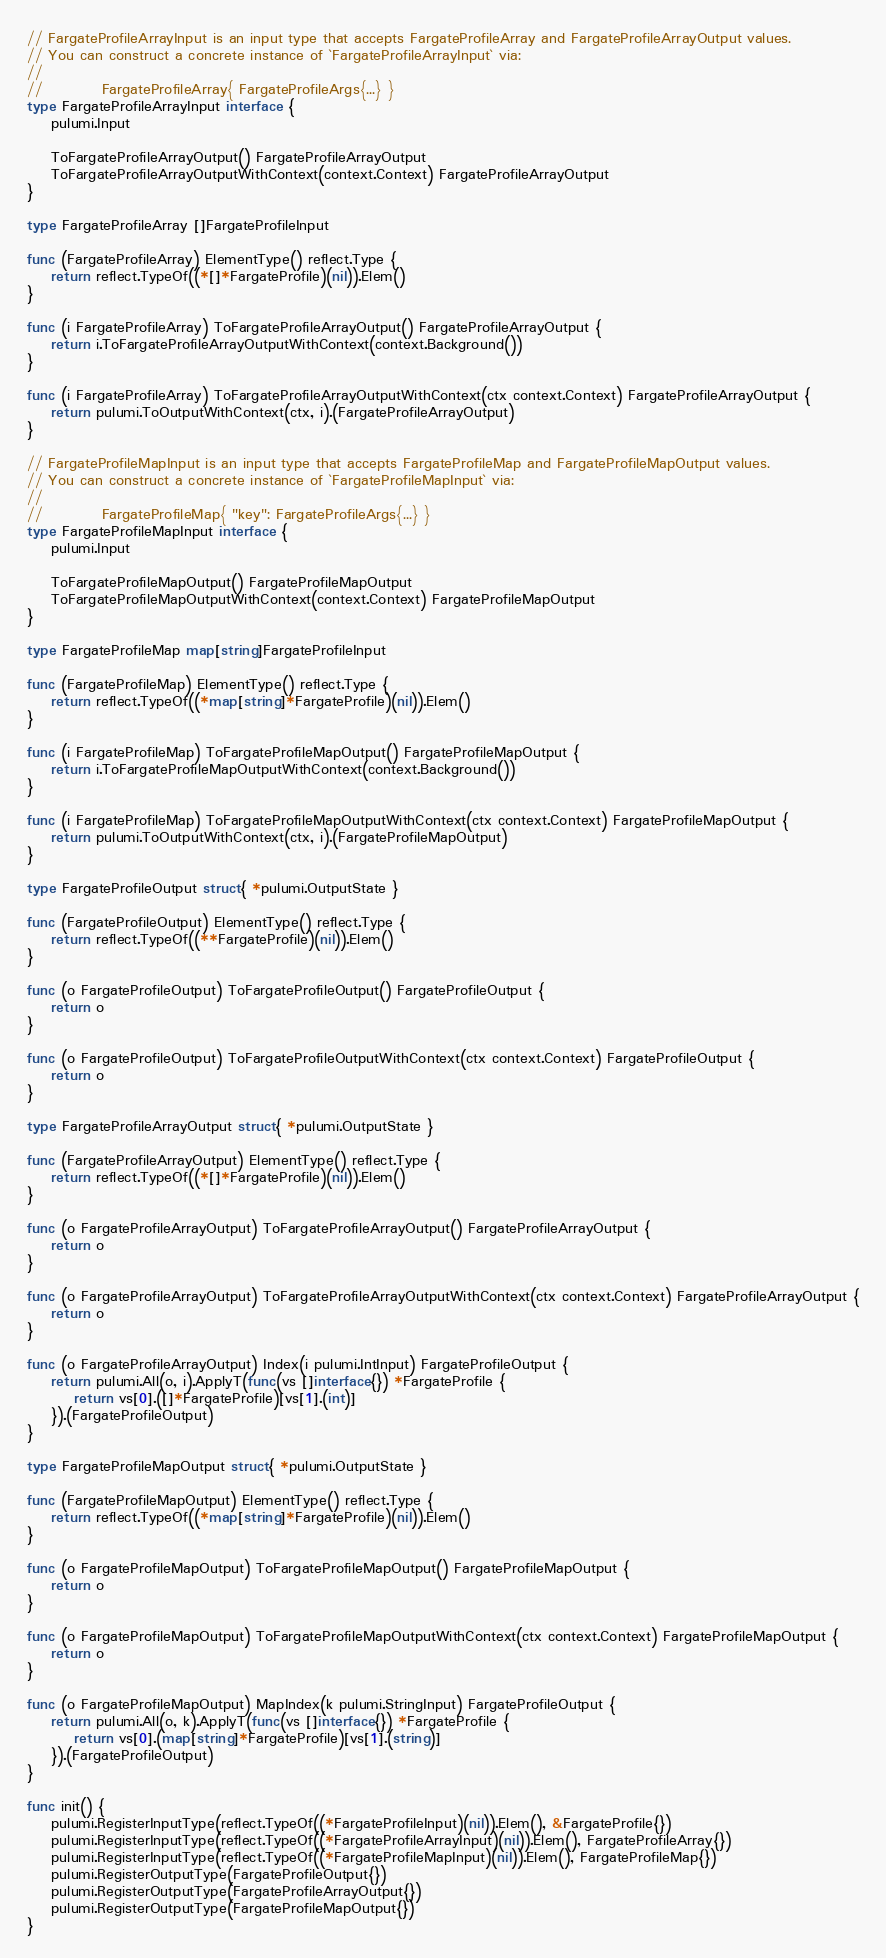<code> <loc_0><loc_0><loc_500><loc_500><_Go_>
// FargateProfileArrayInput is an input type that accepts FargateProfileArray and FargateProfileArrayOutput values.
// You can construct a concrete instance of `FargateProfileArrayInput` via:
//
//          FargateProfileArray{ FargateProfileArgs{...} }
type FargateProfileArrayInput interface {
	pulumi.Input

	ToFargateProfileArrayOutput() FargateProfileArrayOutput
	ToFargateProfileArrayOutputWithContext(context.Context) FargateProfileArrayOutput
}

type FargateProfileArray []FargateProfileInput

func (FargateProfileArray) ElementType() reflect.Type {
	return reflect.TypeOf((*[]*FargateProfile)(nil)).Elem()
}

func (i FargateProfileArray) ToFargateProfileArrayOutput() FargateProfileArrayOutput {
	return i.ToFargateProfileArrayOutputWithContext(context.Background())
}

func (i FargateProfileArray) ToFargateProfileArrayOutputWithContext(ctx context.Context) FargateProfileArrayOutput {
	return pulumi.ToOutputWithContext(ctx, i).(FargateProfileArrayOutput)
}

// FargateProfileMapInput is an input type that accepts FargateProfileMap and FargateProfileMapOutput values.
// You can construct a concrete instance of `FargateProfileMapInput` via:
//
//          FargateProfileMap{ "key": FargateProfileArgs{...} }
type FargateProfileMapInput interface {
	pulumi.Input

	ToFargateProfileMapOutput() FargateProfileMapOutput
	ToFargateProfileMapOutputWithContext(context.Context) FargateProfileMapOutput
}

type FargateProfileMap map[string]FargateProfileInput

func (FargateProfileMap) ElementType() reflect.Type {
	return reflect.TypeOf((*map[string]*FargateProfile)(nil)).Elem()
}

func (i FargateProfileMap) ToFargateProfileMapOutput() FargateProfileMapOutput {
	return i.ToFargateProfileMapOutputWithContext(context.Background())
}

func (i FargateProfileMap) ToFargateProfileMapOutputWithContext(ctx context.Context) FargateProfileMapOutput {
	return pulumi.ToOutputWithContext(ctx, i).(FargateProfileMapOutput)
}

type FargateProfileOutput struct{ *pulumi.OutputState }

func (FargateProfileOutput) ElementType() reflect.Type {
	return reflect.TypeOf((**FargateProfile)(nil)).Elem()
}

func (o FargateProfileOutput) ToFargateProfileOutput() FargateProfileOutput {
	return o
}

func (o FargateProfileOutput) ToFargateProfileOutputWithContext(ctx context.Context) FargateProfileOutput {
	return o
}

type FargateProfileArrayOutput struct{ *pulumi.OutputState }

func (FargateProfileArrayOutput) ElementType() reflect.Type {
	return reflect.TypeOf((*[]*FargateProfile)(nil)).Elem()
}

func (o FargateProfileArrayOutput) ToFargateProfileArrayOutput() FargateProfileArrayOutput {
	return o
}

func (o FargateProfileArrayOutput) ToFargateProfileArrayOutputWithContext(ctx context.Context) FargateProfileArrayOutput {
	return o
}

func (o FargateProfileArrayOutput) Index(i pulumi.IntInput) FargateProfileOutput {
	return pulumi.All(o, i).ApplyT(func(vs []interface{}) *FargateProfile {
		return vs[0].([]*FargateProfile)[vs[1].(int)]
	}).(FargateProfileOutput)
}

type FargateProfileMapOutput struct{ *pulumi.OutputState }

func (FargateProfileMapOutput) ElementType() reflect.Type {
	return reflect.TypeOf((*map[string]*FargateProfile)(nil)).Elem()
}

func (o FargateProfileMapOutput) ToFargateProfileMapOutput() FargateProfileMapOutput {
	return o
}

func (o FargateProfileMapOutput) ToFargateProfileMapOutputWithContext(ctx context.Context) FargateProfileMapOutput {
	return o
}

func (o FargateProfileMapOutput) MapIndex(k pulumi.StringInput) FargateProfileOutput {
	return pulumi.All(o, k).ApplyT(func(vs []interface{}) *FargateProfile {
		return vs[0].(map[string]*FargateProfile)[vs[1].(string)]
	}).(FargateProfileOutput)
}

func init() {
	pulumi.RegisterInputType(reflect.TypeOf((*FargateProfileInput)(nil)).Elem(), &FargateProfile{})
	pulumi.RegisterInputType(reflect.TypeOf((*FargateProfileArrayInput)(nil)).Elem(), FargateProfileArray{})
	pulumi.RegisterInputType(reflect.TypeOf((*FargateProfileMapInput)(nil)).Elem(), FargateProfileMap{})
	pulumi.RegisterOutputType(FargateProfileOutput{})
	pulumi.RegisterOutputType(FargateProfileArrayOutput{})
	pulumi.RegisterOutputType(FargateProfileMapOutput{})
}
</code> 